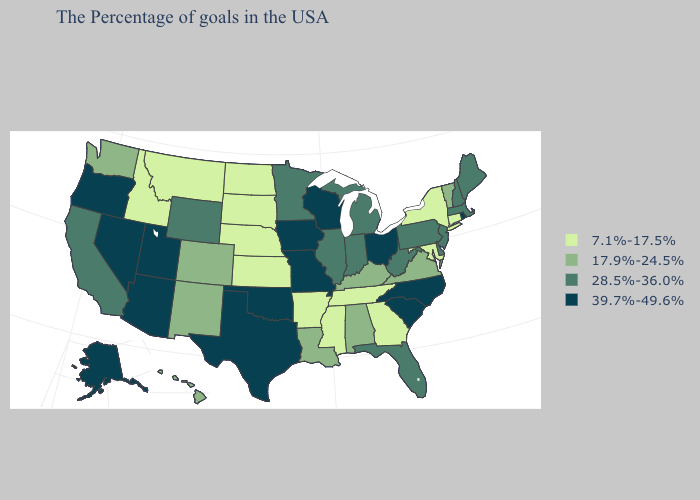Does Oregon have the highest value in the West?
Give a very brief answer. Yes. Name the states that have a value in the range 7.1%-17.5%?
Answer briefly. Connecticut, New York, Maryland, Georgia, Tennessee, Mississippi, Arkansas, Kansas, Nebraska, South Dakota, North Dakota, Montana, Idaho. Does Mississippi have the lowest value in the South?
Concise answer only. Yes. What is the lowest value in the USA?
Write a very short answer. 7.1%-17.5%. Name the states that have a value in the range 17.9%-24.5%?
Give a very brief answer. Vermont, Virginia, Kentucky, Alabama, Louisiana, Colorado, New Mexico, Washington, Hawaii. Which states have the lowest value in the South?
Keep it brief. Maryland, Georgia, Tennessee, Mississippi, Arkansas. Which states have the lowest value in the USA?
Quick response, please. Connecticut, New York, Maryland, Georgia, Tennessee, Mississippi, Arkansas, Kansas, Nebraska, South Dakota, North Dakota, Montana, Idaho. Name the states that have a value in the range 39.7%-49.6%?
Write a very short answer. Rhode Island, North Carolina, South Carolina, Ohio, Wisconsin, Missouri, Iowa, Oklahoma, Texas, Utah, Arizona, Nevada, Oregon, Alaska. Which states have the lowest value in the South?
Short answer required. Maryland, Georgia, Tennessee, Mississippi, Arkansas. Among the states that border Maryland , which have the lowest value?
Concise answer only. Virginia. Does Hawaii have the lowest value in the USA?
Concise answer only. No. Does Florida have a higher value than Kansas?
Write a very short answer. Yes. Which states have the highest value in the USA?
Concise answer only. Rhode Island, North Carolina, South Carolina, Ohio, Wisconsin, Missouri, Iowa, Oklahoma, Texas, Utah, Arizona, Nevada, Oregon, Alaska. What is the lowest value in the USA?
Give a very brief answer. 7.1%-17.5%. Among the states that border Massachusetts , which have the lowest value?
Short answer required. Connecticut, New York. 